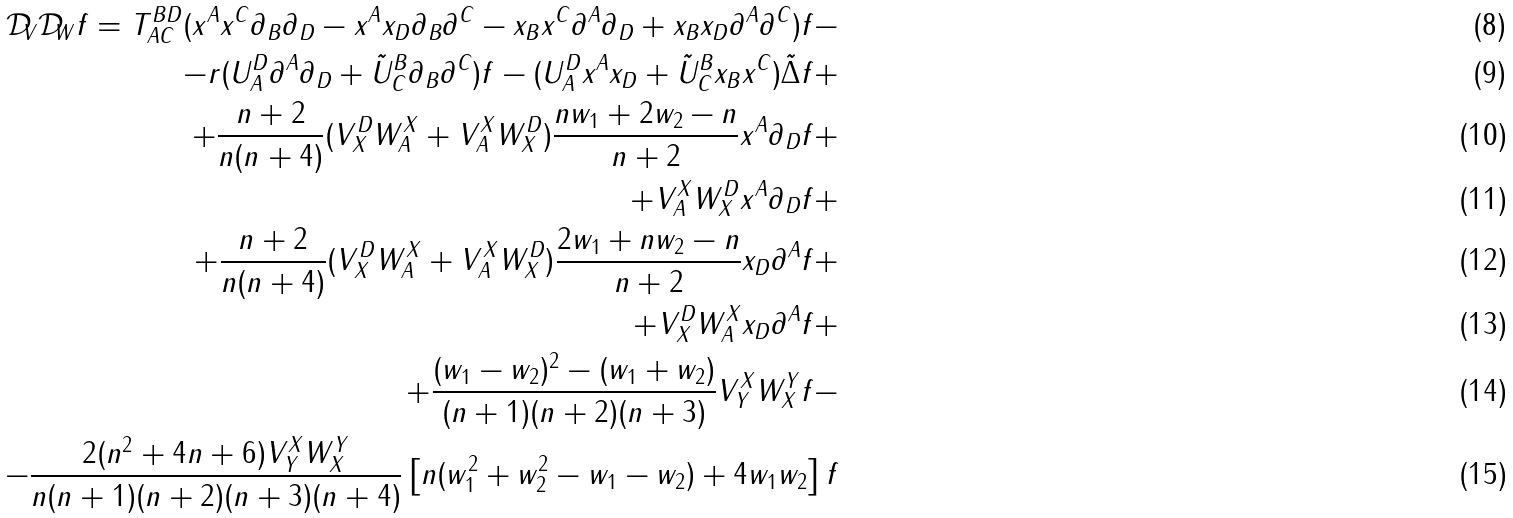<formula> <loc_0><loc_0><loc_500><loc_500>\mathcal { D } _ { V } \mathcal { D } _ { W } f = T ^ { B D } _ { A C } ( x ^ { A } x ^ { C } \partial _ { B } \partial _ { D } - x ^ { A } x _ { D } \partial _ { B } \partial ^ { C } - x _ { B } x ^ { C } \partial ^ { A } \partial _ { D } + x _ { B } x _ { D } \partial ^ { A } \partial ^ { C } ) f - \\ - r ( U ^ { D } _ { A } \partial ^ { A } \partial _ { D } + \tilde { U } ^ { B } _ { C } \partial _ { B } \partial ^ { C } ) f - ( U ^ { D } _ { A } x ^ { A } x _ { D } + \tilde { U } ^ { B } _ { C } x _ { B } x ^ { C } ) \tilde { \Delta } f + \\ + \frac { n + 2 } { n ( n + 4 ) } ( V ^ { D } _ { X } W ^ { X } _ { A } + V ^ { X } _ { A } W ^ { D } _ { X } ) \frac { n w _ { 1 } + 2 w _ { 2 } - n } { n + 2 } x ^ { A } \partial _ { D } f + \\ + V ^ { X } _ { A } W ^ { D } _ { X } x ^ { A } \partial _ { D } f + \\ + \frac { n + 2 } { n ( n + 4 ) } ( V ^ { D } _ { X } W ^ { X } _ { A } + V ^ { X } _ { A } W ^ { D } _ { X } ) \frac { 2 w _ { 1 } + n w _ { 2 } - n } { n + 2 } x _ { D } \partial ^ { A } f + \\ + V ^ { D } _ { X } W ^ { X } _ { A } x _ { D } \partial ^ { A } f + \\ + \frac { ( w _ { 1 } - w _ { 2 } ) ^ { 2 } - ( w _ { 1 } + w _ { 2 } ) } { ( n + 1 ) ( n + 2 ) ( n + 3 ) } V ^ { X } _ { Y } W ^ { Y } _ { X } f - \\ - \frac { 2 ( n ^ { 2 } + 4 n + 6 ) V ^ { X } _ { Y } W ^ { Y } _ { X } } { n ( n + 1 ) ( n + 2 ) ( n + 3 ) ( n + 4 ) } \left [ n ( w _ { 1 } ^ { 2 } + w _ { 2 } ^ { 2 } - w _ { 1 } - w _ { 2 } ) + 4 w _ { 1 } w _ { 2 } \right ] f</formula> 